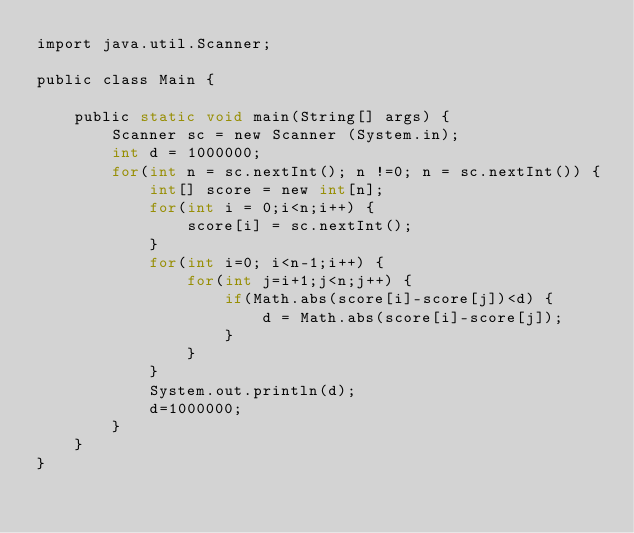Convert code to text. <code><loc_0><loc_0><loc_500><loc_500><_C_>import java.util.Scanner;

public class Main {

	public static void main(String[] args) {
		Scanner sc = new Scanner (System.in);
		int d = 1000000;
		for(int n = sc.nextInt(); n !=0; n = sc.nextInt()) {
			int[] score = new int[n];
			for(int i = 0;i<n;i++) {
				score[i] = sc.nextInt();
			}
			for(int i=0; i<n-1;i++) {
				for(int j=i+1;j<n;j++) {
					if(Math.abs(score[i]-score[j])<d) {
						d = Math.abs(score[i]-score[j]);
					}
				}
			}
			System.out.println(d);
			d=1000000;
		}
	}
}

</code> 